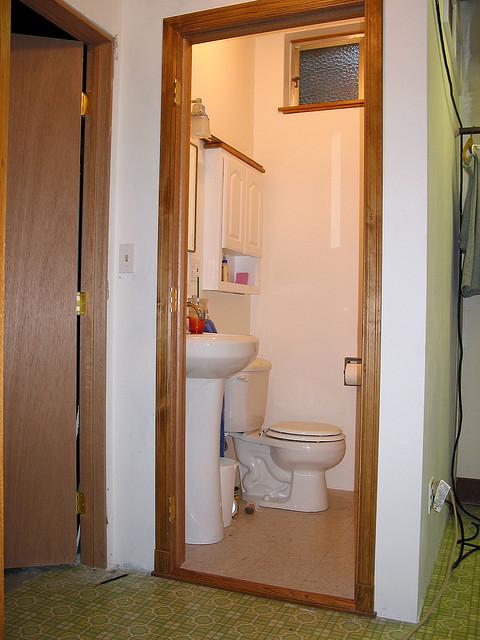Where in this scene would one likely store medication?
Concise answer only. Cabinet. Is this picture of a kitchen?
Concise answer only. No. Is there a window in the bathroom?
Write a very short answer. Yes. What is shining through the window?
Answer briefly. Light. IS there a bathtub in here?
Write a very short answer. No. 